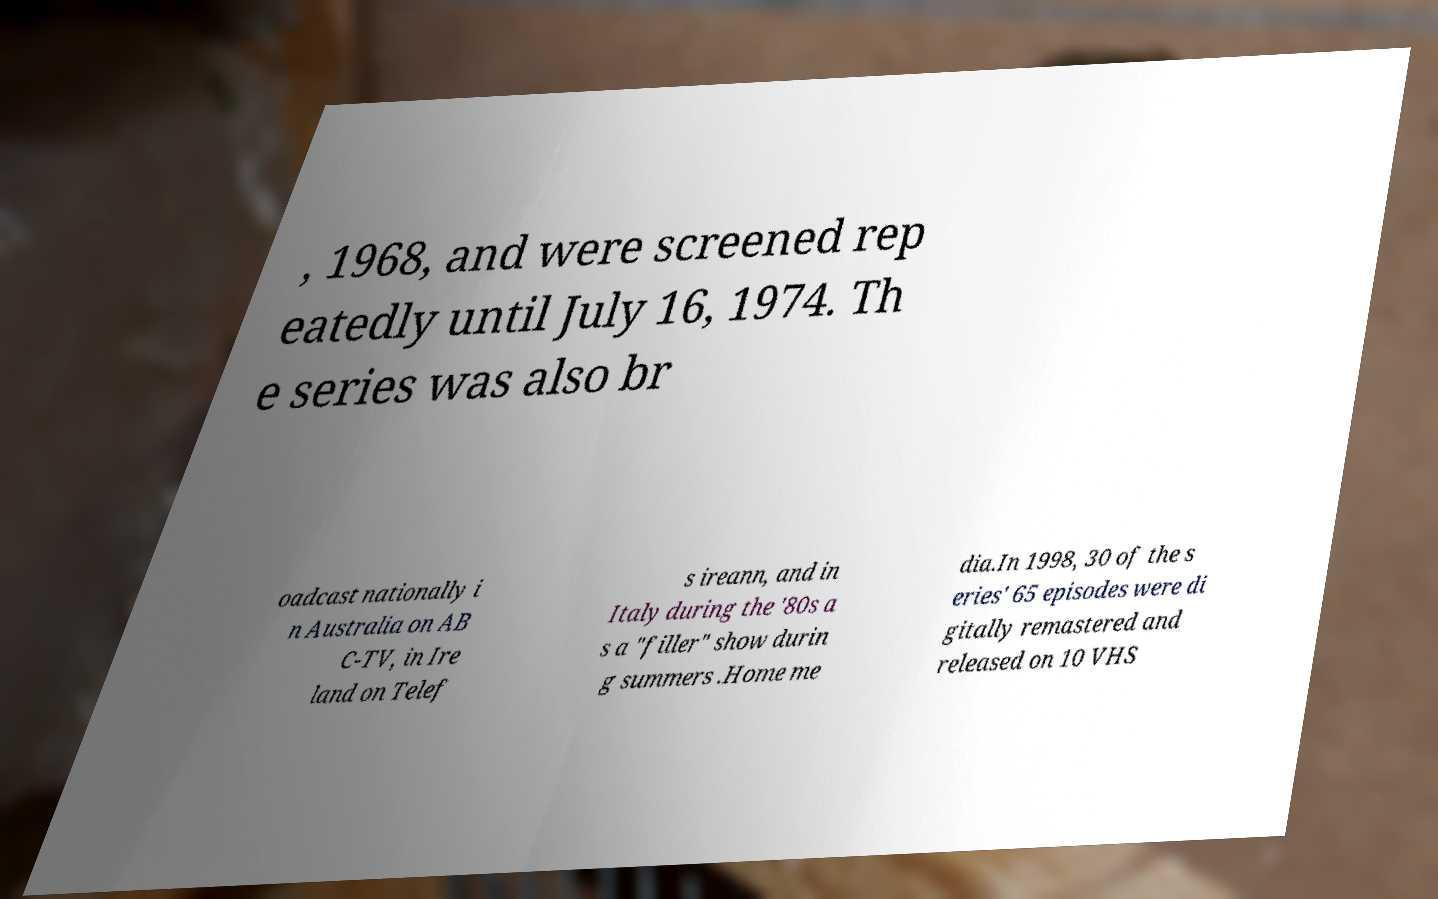Could you extract and type out the text from this image? , 1968, and were screened rep eatedly until July 16, 1974. Th e series was also br oadcast nationally i n Australia on AB C-TV, in Ire land on Telef s ireann, and in Italy during the '80s a s a "filler" show durin g summers .Home me dia.In 1998, 30 of the s eries' 65 episodes were di gitally remastered and released on 10 VHS 